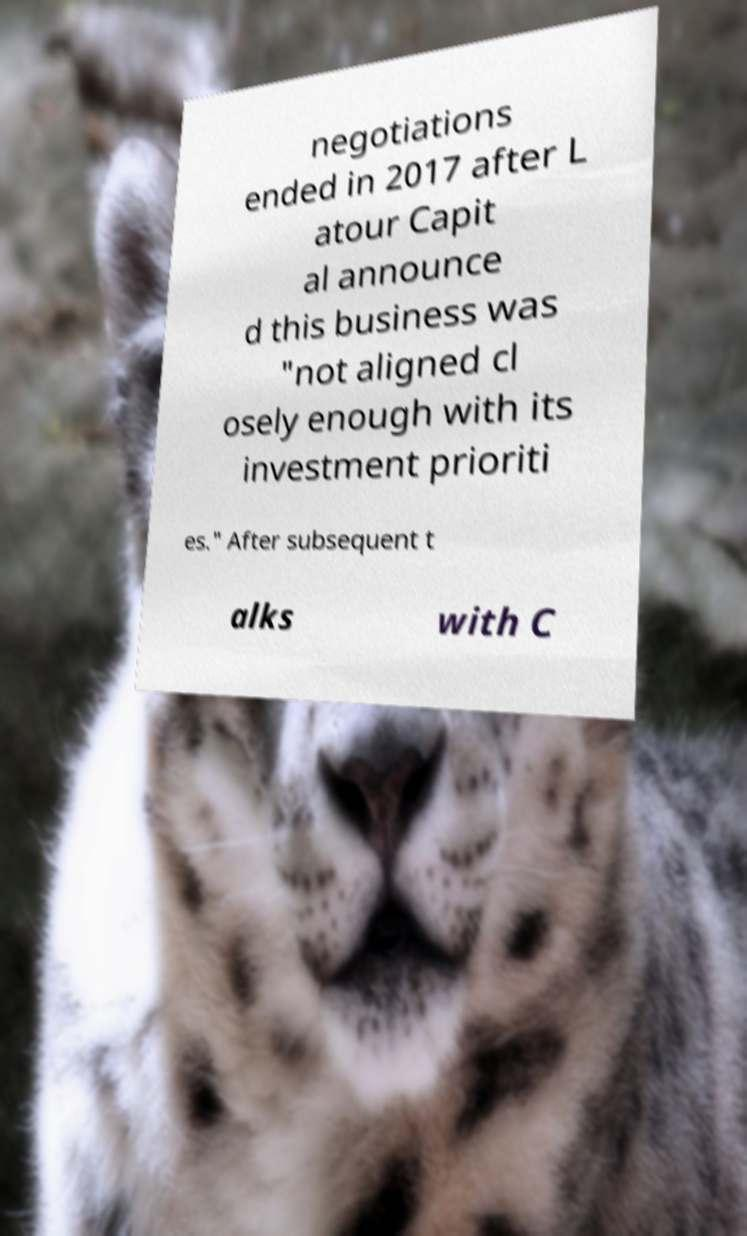What messages or text are displayed in this image? I need them in a readable, typed format. negotiations ended in 2017 after L atour Capit al announce d this business was "not aligned cl osely enough with its investment prioriti es." After subsequent t alks with C 